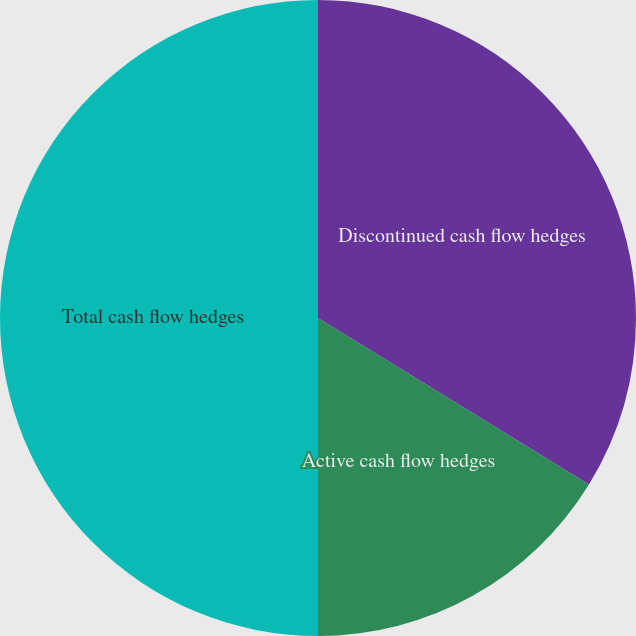Convert chart. <chart><loc_0><loc_0><loc_500><loc_500><pie_chart><fcel>Discontinued cash flow hedges<fcel>Active cash flow hedges<fcel>Total cash flow hedges<nl><fcel>33.77%<fcel>16.23%<fcel>50.0%<nl></chart> 